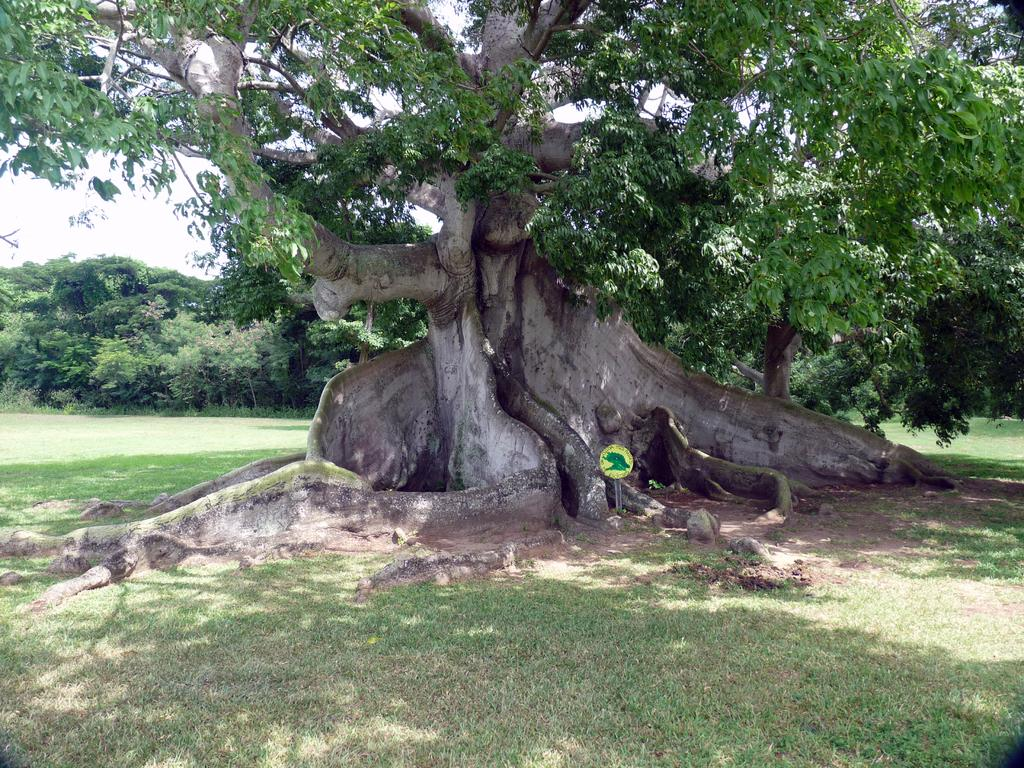What type of vegetation can be seen in the image? There are trees in the image. What is placed in front of one of the trees? There is a board in front of a tree. What covers the ground in the image? There is grass on the ground. What can be seen in the distance in the image? The sky is visible in the background of the image. Can you see any feet walking on the grass in the image? There are no feet or people walking visible in the image. Is there a kettle hanging from one of the trees in the image? There is no kettle present in the image. 